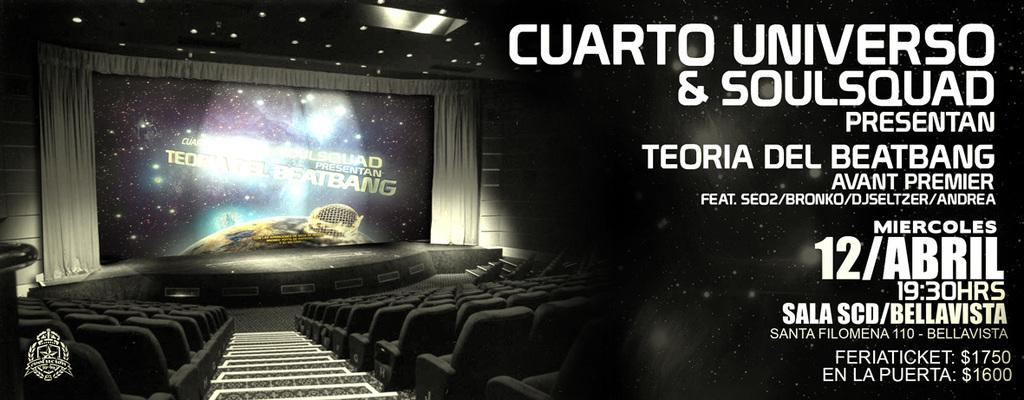What type of furniture can be seen in the image? There are chairs in the image. What else is present in the image besides the chairs? There is a screen in the image. Can you see a toad sitting on the screen in the image? No, there is no toad present in the image. What type of iron is being used to cook on the range in the image? There is no range or iron present in the image; it only features chairs and a screen. 